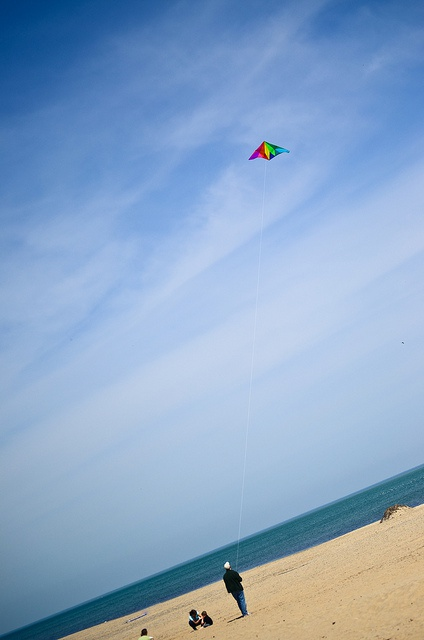Describe the objects in this image and their specific colors. I can see people in darkblue, black, blue, navy, and gray tones, kite in darkblue, brown, lime, teal, and lightblue tones, people in darkblue, black, tan, and beige tones, people in darkblue, black, maroon, and gray tones, and people in darkblue, khaki, black, gray, and tan tones in this image. 